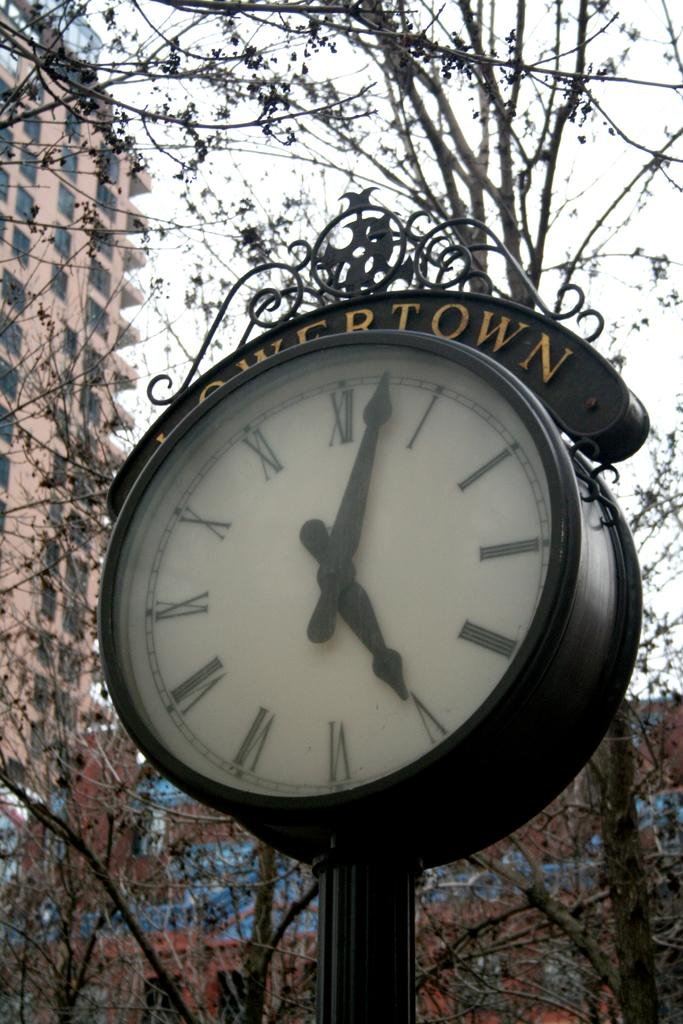<image>
Describe the image concisely. A clock from Lowertown shows that is is 5:02 and stands outside in a park. 